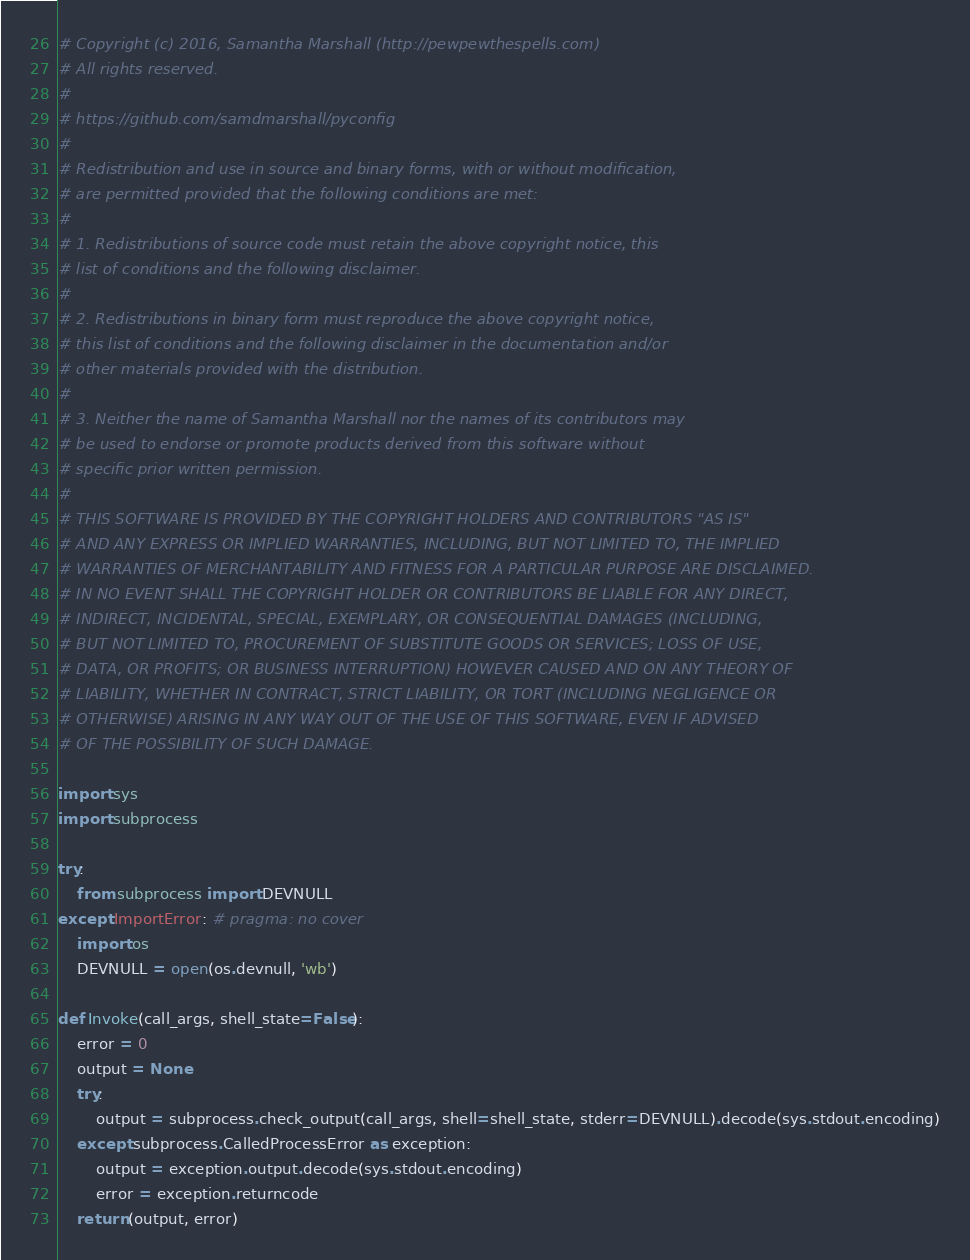Convert code to text. <code><loc_0><loc_0><loc_500><loc_500><_Python_># Copyright (c) 2016, Samantha Marshall (http://pewpewthespells.com)
# All rights reserved.
#
# https://github.com/samdmarshall/pyconfig
#
# Redistribution and use in source and binary forms, with or without modification,
# are permitted provided that the following conditions are met:
#
# 1. Redistributions of source code must retain the above copyright notice, this
# list of conditions and the following disclaimer.
#
# 2. Redistributions in binary form must reproduce the above copyright notice,
# this list of conditions and the following disclaimer in the documentation and/or
# other materials provided with the distribution.
#
# 3. Neither the name of Samantha Marshall nor the names of its contributors may
# be used to endorse or promote products derived from this software without
# specific prior written permission.
#
# THIS SOFTWARE IS PROVIDED BY THE COPYRIGHT HOLDERS AND CONTRIBUTORS "AS IS"
# AND ANY EXPRESS OR IMPLIED WARRANTIES, INCLUDING, BUT NOT LIMITED TO, THE IMPLIED
# WARRANTIES OF MERCHANTABILITY AND FITNESS FOR A PARTICULAR PURPOSE ARE DISCLAIMED.
# IN NO EVENT SHALL THE COPYRIGHT HOLDER OR CONTRIBUTORS BE LIABLE FOR ANY DIRECT,
# INDIRECT, INCIDENTAL, SPECIAL, EXEMPLARY, OR CONSEQUENTIAL DAMAGES (INCLUDING,
# BUT NOT LIMITED TO, PROCUREMENT OF SUBSTITUTE GOODS OR SERVICES; LOSS OF USE,
# DATA, OR PROFITS; OR BUSINESS INTERRUPTION) HOWEVER CAUSED AND ON ANY THEORY OF
# LIABILITY, WHETHER IN CONTRACT, STRICT LIABILITY, OR TORT (INCLUDING NEGLIGENCE OR
# OTHERWISE) ARISING IN ANY WAY OUT OF THE USE OF THIS SOFTWARE, EVEN IF ADVISED
# OF THE POSSIBILITY OF SUCH DAMAGE.

import sys
import subprocess

try:
    from subprocess import DEVNULL
except ImportError: # pragma: no cover
    import os
    DEVNULL = open(os.devnull, 'wb')

def Invoke(call_args, shell_state=False):
    error = 0
    output = None
    try:
        output = subprocess.check_output(call_args, shell=shell_state, stderr=DEVNULL).decode(sys.stdout.encoding)
    except subprocess.CalledProcessError as exception:
        output = exception.output.decode(sys.stdout.encoding)
        error = exception.returncode
    return (output, error)
</code> 